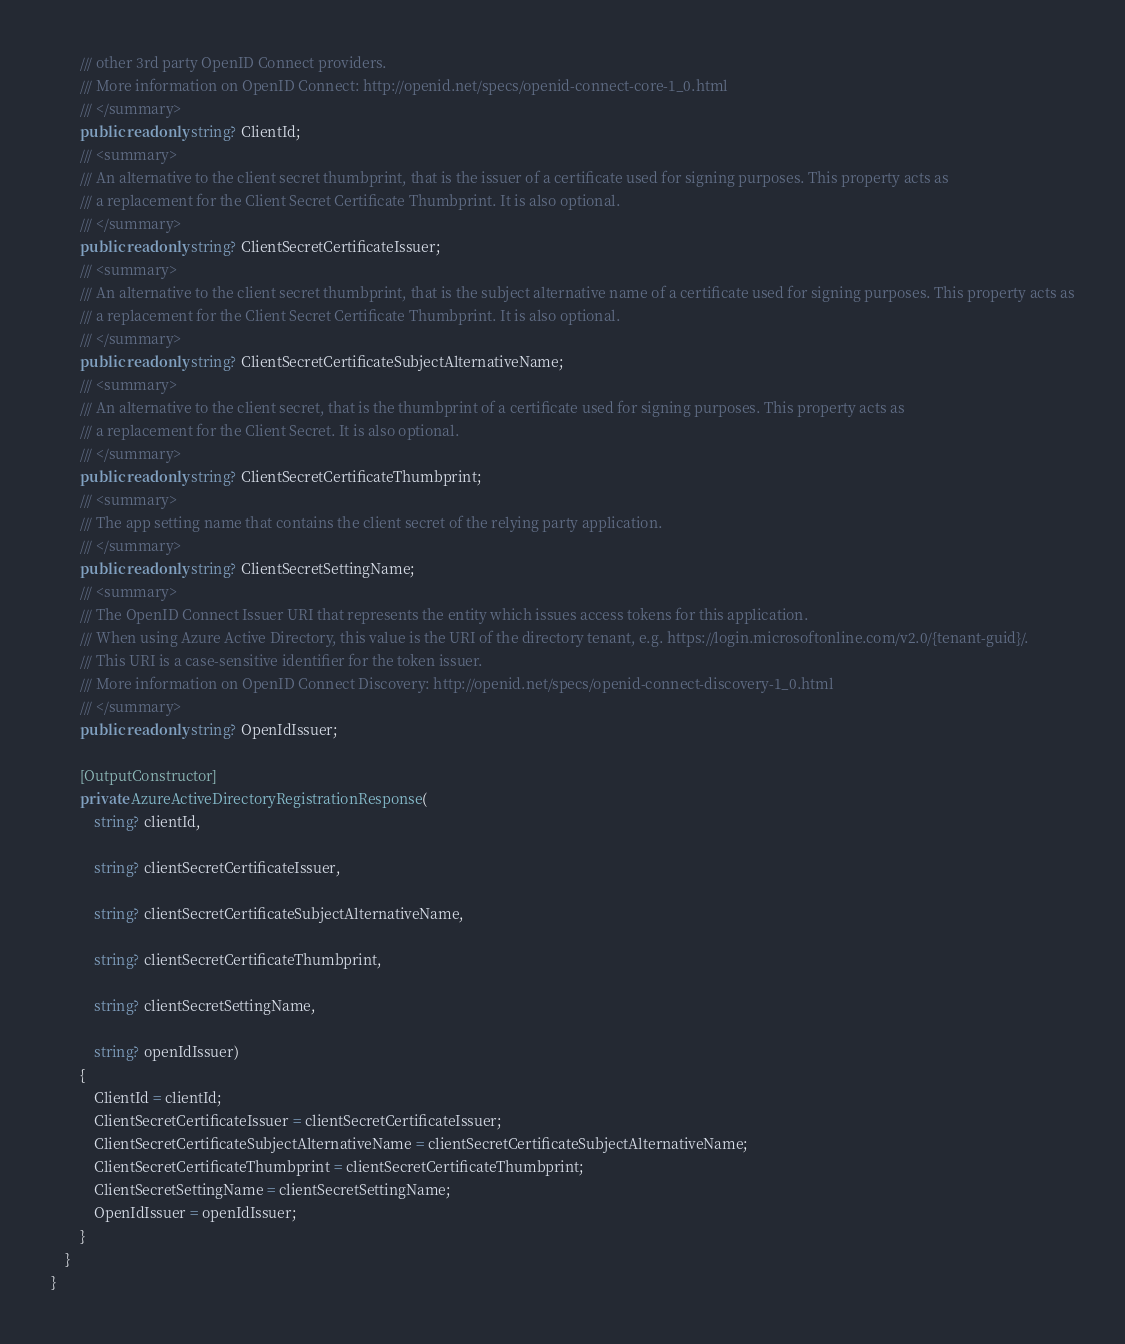<code> <loc_0><loc_0><loc_500><loc_500><_C#_>        /// other 3rd party OpenID Connect providers.
        /// More information on OpenID Connect: http://openid.net/specs/openid-connect-core-1_0.html
        /// </summary>
        public readonly string? ClientId;
        /// <summary>
        /// An alternative to the client secret thumbprint, that is the issuer of a certificate used for signing purposes. This property acts as
        /// a replacement for the Client Secret Certificate Thumbprint. It is also optional.
        /// </summary>
        public readonly string? ClientSecretCertificateIssuer;
        /// <summary>
        /// An alternative to the client secret thumbprint, that is the subject alternative name of a certificate used for signing purposes. This property acts as
        /// a replacement for the Client Secret Certificate Thumbprint. It is also optional.
        /// </summary>
        public readonly string? ClientSecretCertificateSubjectAlternativeName;
        /// <summary>
        /// An alternative to the client secret, that is the thumbprint of a certificate used for signing purposes. This property acts as
        /// a replacement for the Client Secret. It is also optional.
        /// </summary>
        public readonly string? ClientSecretCertificateThumbprint;
        /// <summary>
        /// The app setting name that contains the client secret of the relying party application.
        /// </summary>
        public readonly string? ClientSecretSettingName;
        /// <summary>
        /// The OpenID Connect Issuer URI that represents the entity which issues access tokens for this application.
        /// When using Azure Active Directory, this value is the URI of the directory tenant, e.g. https://login.microsoftonline.com/v2.0/{tenant-guid}/.
        /// This URI is a case-sensitive identifier for the token issuer.
        /// More information on OpenID Connect Discovery: http://openid.net/specs/openid-connect-discovery-1_0.html
        /// </summary>
        public readonly string? OpenIdIssuer;

        [OutputConstructor]
        private AzureActiveDirectoryRegistrationResponse(
            string? clientId,

            string? clientSecretCertificateIssuer,

            string? clientSecretCertificateSubjectAlternativeName,

            string? clientSecretCertificateThumbprint,

            string? clientSecretSettingName,

            string? openIdIssuer)
        {
            ClientId = clientId;
            ClientSecretCertificateIssuer = clientSecretCertificateIssuer;
            ClientSecretCertificateSubjectAlternativeName = clientSecretCertificateSubjectAlternativeName;
            ClientSecretCertificateThumbprint = clientSecretCertificateThumbprint;
            ClientSecretSettingName = clientSecretSettingName;
            OpenIdIssuer = openIdIssuer;
        }
    }
}
</code> 